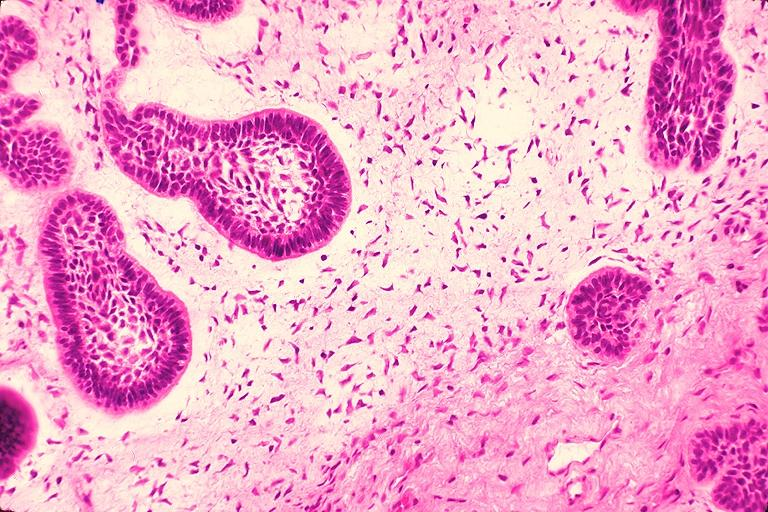does this image show ameloblastic fibroma?
Answer the question using a single word or phrase. Yes 